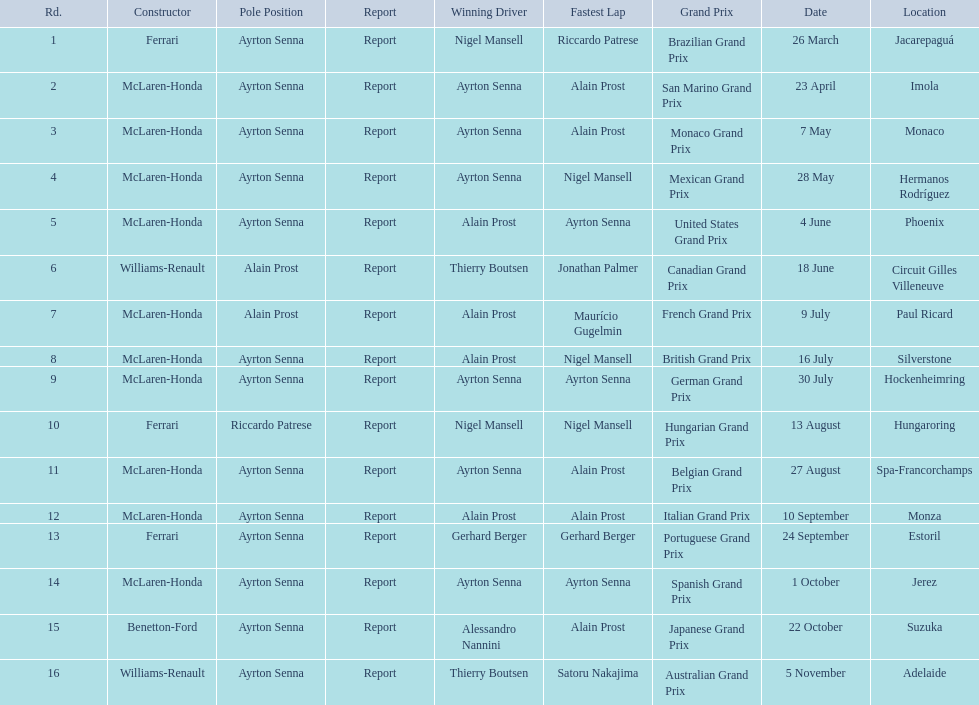Who won the spanish grand prix? McLaren-Honda. Who won the italian grand prix? McLaren-Honda. What grand prix did benneton-ford win? Japanese Grand Prix. 